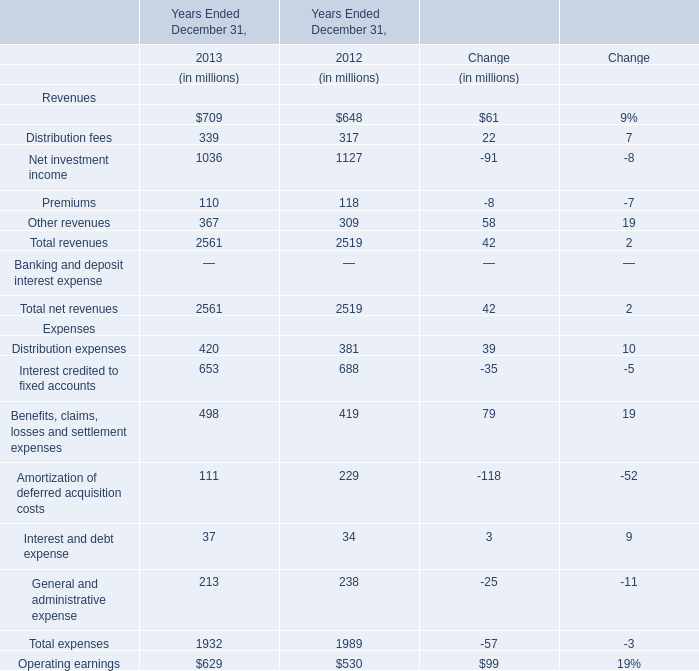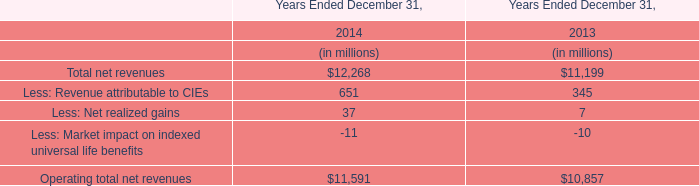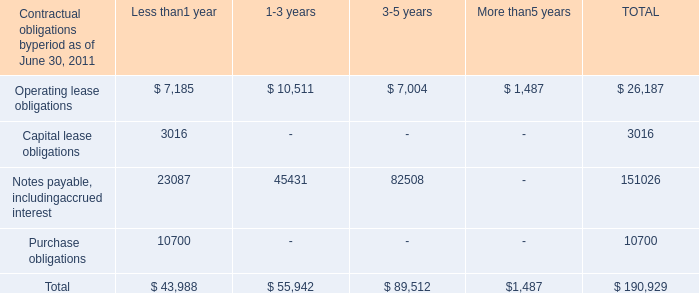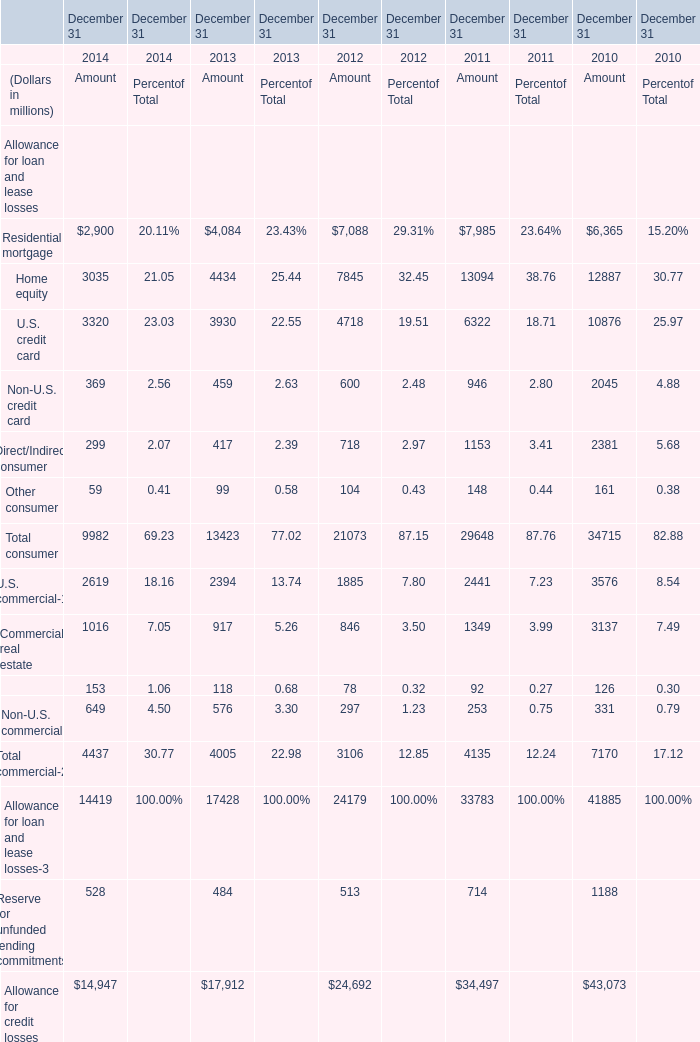what's the total amount of Operating lease obligations of TOTAL is, and U.S. credit card of December 31 2010 Amount ? 
Computations: (26187.0 + 10876.0)
Answer: 37063.0. 